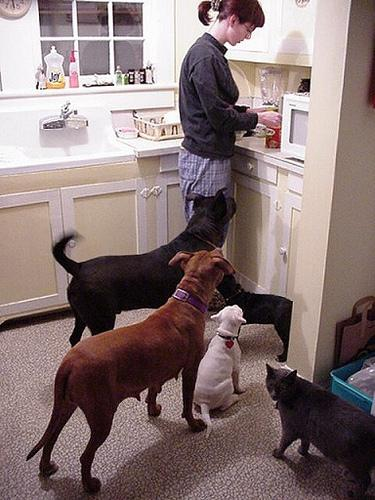Question: why are animals gathered together?
Choices:
A. Playing.
B. Eating.
C. Fighting.
D. Waiting to eat.
Answer with the letter. Answer: D Question: what is white?
Choices:
A. The plate.
B. A dog.
C. The shoe.
D. The snow.
Answer with the letter. Answer: B Question: who is fixing food?
Choices:
A. The chef.
B. The mom.
C. The cook.
D. A woman.
Answer with the letter. Answer: D Question: what color is a microwave?
Choices:
A. Silver.
B. Black.
C. White.
D. Gray.
Answer with the letter. Answer: C Question: what is brown?
Choices:
A. Dirt.
B. Shoe.
C. One dog.
D. House.
Answer with the letter. Answer: C Question: how many animals are there?
Choices:
A. Four.
B. Two.
C. Five.
D. One.
Answer with the letter. Answer: C 